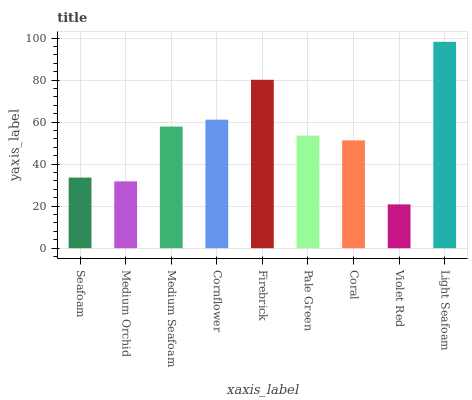Is Violet Red the minimum?
Answer yes or no. Yes. Is Light Seafoam the maximum?
Answer yes or no. Yes. Is Medium Orchid the minimum?
Answer yes or no. No. Is Medium Orchid the maximum?
Answer yes or no. No. Is Seafoam greater than Medium Orchid?
Answer yes or no. Yes. Is Medium Orchid less than Seafoam?
Answer yes or no. Yes. Is Medium Orchid greater than Seafoam?
Answer yes or no. No. Is Seafoam less than Medium Orchid?
Answer yes or no. No. Is Pale Green the high median?
Answer yes or no. Yes. Is Pale Green the low median?
Answer yes or no. Yes. Is Firebrick the high median?
Answer yes or no. No. Is Medium Orchid the low median?
Answer yes or no. No. 